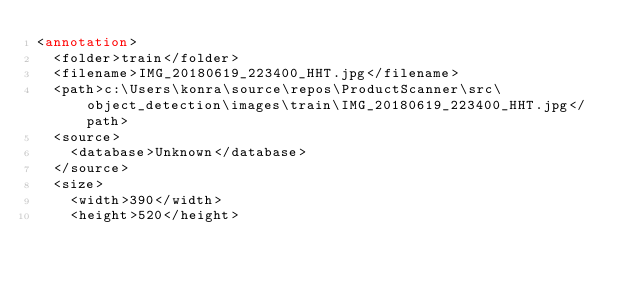Convert code to text. <code><loc_0><loc_0><loc_500><loc_500><_XML_><annotation>
	<folder>train</folder>
	<filename>IMG_20180619_223400_HHT.jpg</filename>
	<path>c:\Users\konra\source\repos\ProductScanner\src\object_detection\images\train\IMG_20180619_223400_HHT.jpg</path>
	<source>
		<database>Unknown</database>
	</source>
	<size>
		<width>390</width>
		<height>520</height></code> 